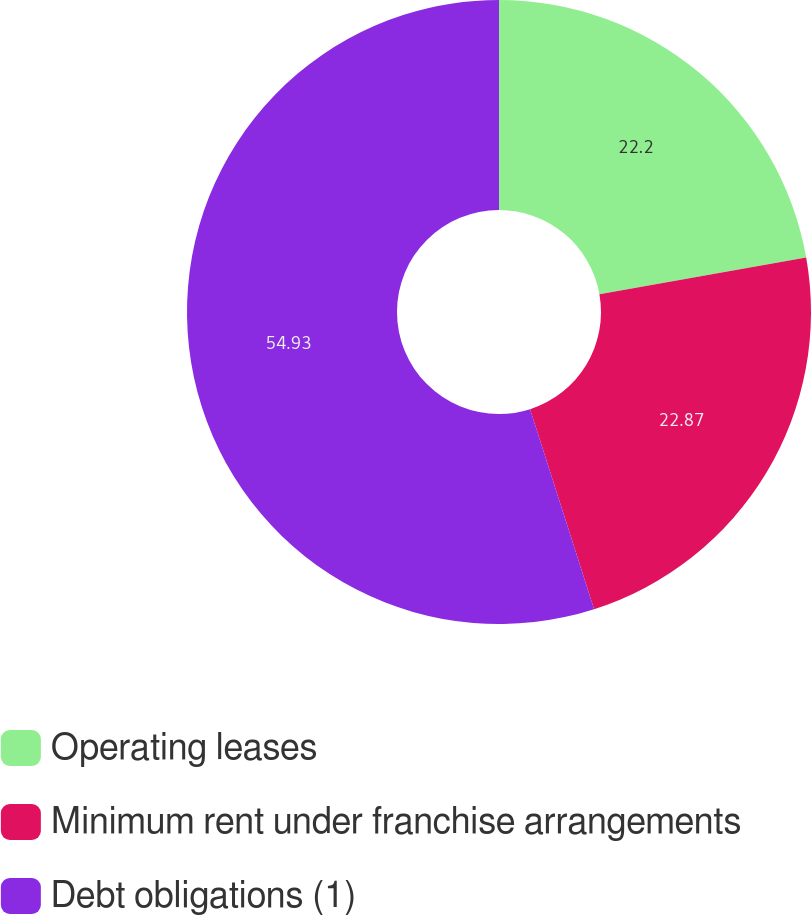Convert chart to OTSL. <chart><loc_0><loc_0><loc_500><loc_500><pie_chart><fcel>Operating leases<fcel>Minimum rent under franchise arrangements<fcel>Debt obligations (1)<nl><fcel>22.2%<fcel>22.87%<fcel>54.93%<nl></chart> 